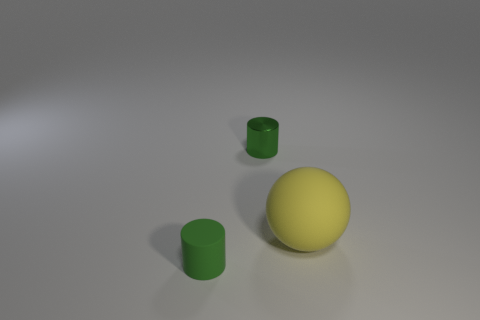Add 3 large rubber objects. How many objects exist? 6 Subtract all spheres. How many objects are left? 2 Subtract 0 cyan spheres. How many objects are left? 3 Subtract all tiny green things. Subtract all big rubber objects. How many objects are left? 0 Add 3 yellow rubber spheres. How many yellow rubber spheres are left? 4 Add 2 tiny matte cylinders. How many tiny matte cylinders exist? 3 